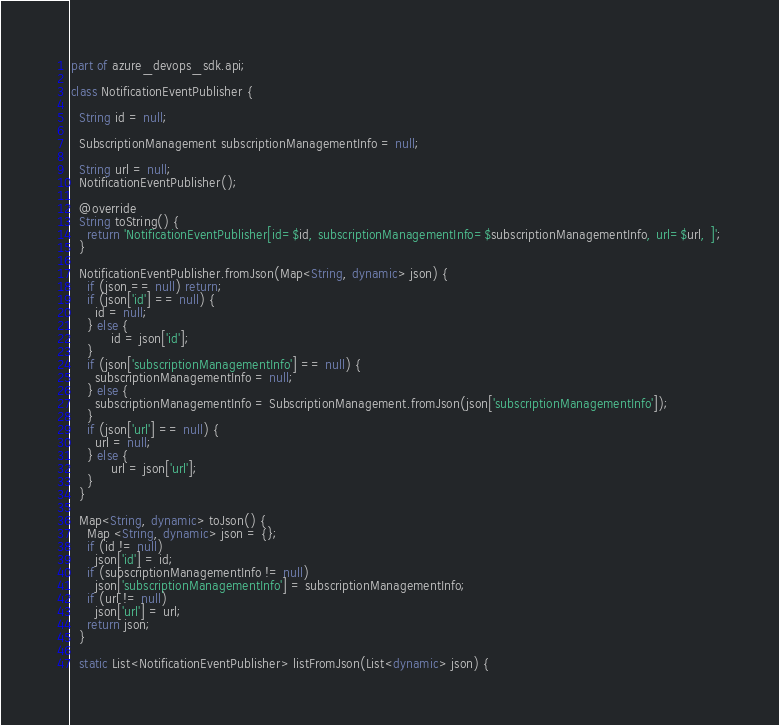Convert code to text. <code><loc_0><loc_0><loc_500><loc_500><_Dart_>part of azure_devops_sdk.api;

class NotificationEventPublisher {
  
  String id = null;
  
  SubscriptionManagement subscriptionManagementInfo = null;
  
  String url = null;
  NotificationEventPublisher();

  @override
  String toString() {
    return 'NotificationEventPublisher[id=$id, subscriptionManagementInfo=$subscriptionManagementInfo, url=$url, ]';
  }

  NotificationEventPublisher.fromJson(Map<String, dynamic> json) {
    if (json == null) return;
    if (json['id'] == null) {
      id = null;
    } else {
          id = json['id'];
    }
    if (json['subscriptionManagementInfo'] == null) {
      subscriptionManagementInfo = null;
    } else {
      subscriptionManagementInfo = SubscriptionManagement.fromJson(json['subscriptionManagementInfo']);
    }
    if (json['url'] == null) {
      url = null;
    } else {
          url = json['url'];
    }
  }

  Map<String, dynamic> toJson() {
    Map <String, dynamic> json = {};
    if (id != null)
      json['id'] = id;
    if (subscriptionManagementInfo != null)
      json['subscriptionManagementInfo'] = subscriptionManagementInfo;
    if (url != null)
      json['url'] = url;
    return json;
  }

  static List<NotificationEventPublisher> listFromJson(List<dynamic> json) {</code> 